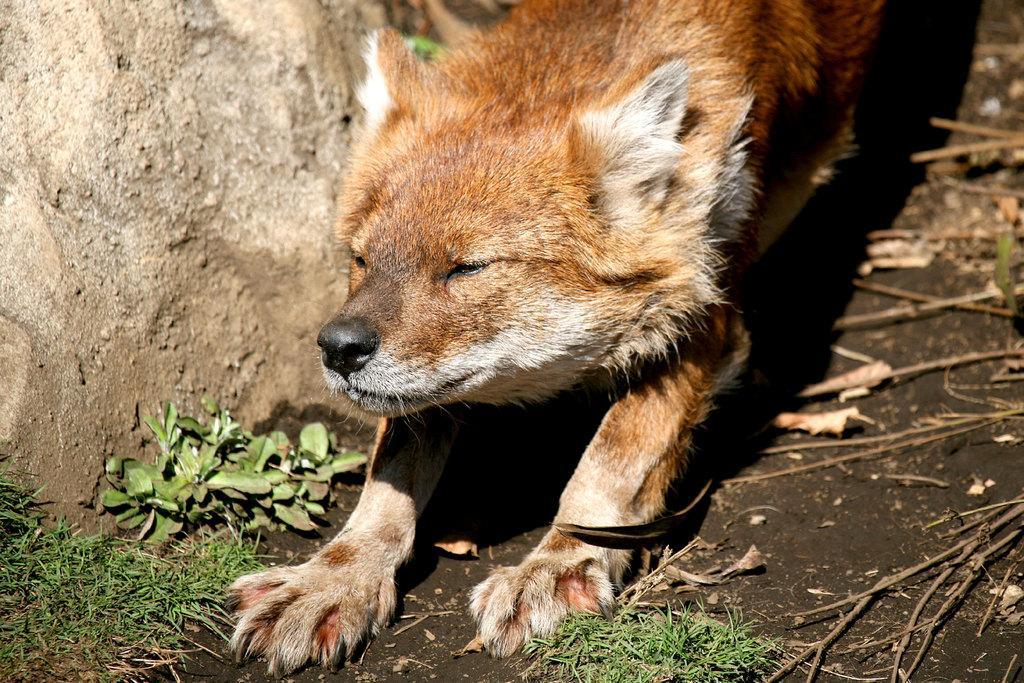How would you summarize this image in a sentence or two? In this image there is a fox, beside the fox there is a rock, in front of the fox there is grass on the surface. 